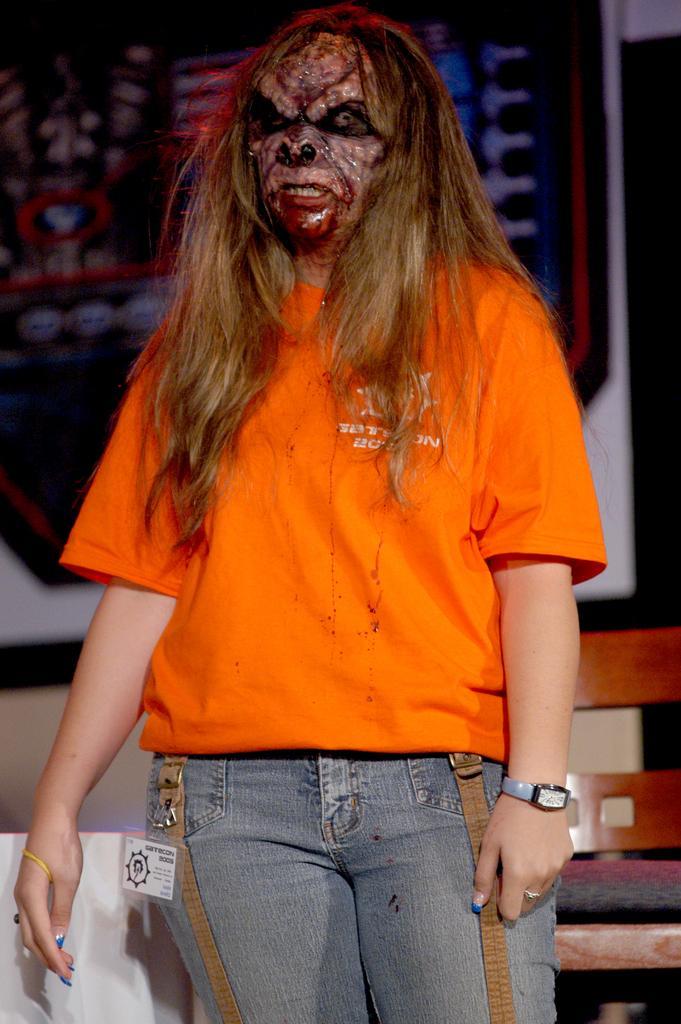Could you give a brief overview of what you see in this image? In this image we can see a person standing on the floor, behind the person there is a chair. In the background there is a frame attached to the wall. 